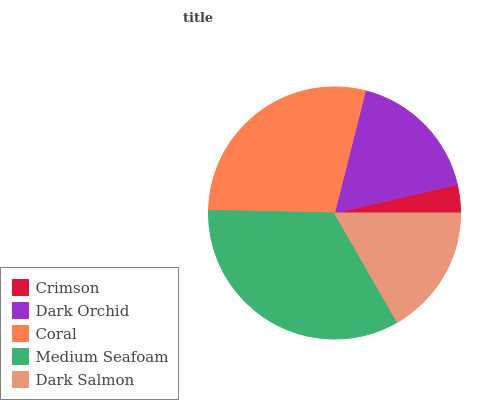Is Crimson the minimum?
Answer yes or no. Yes. Is Medium Seafoam the maximum?
Answer yes or no. Yes. Is Dark Orchid the minimum?
Answer yes or no. No. Is Dark Orchid the maximum?
Answer yes or no. No. Is Dark Orchid greater than Crimson?
Answer yes or no. Yes. Is Crimson less than Dark Orchid?
Answer yes or no. Yes. Is Crimson greater than Dark Orchid?
Answer yes or no. No. Is Dark Orchid less than Crimson?
Answer yes or no. No. Is Dark Orchid the high median?
Answer yes or no. Yes. Is Dark Orchid the low median?
Answer yes or no. Yes. Is Coral the high median?
Answer yes or no. No. Is Medium Seafoam the low median?
Answer yes or no. No. 